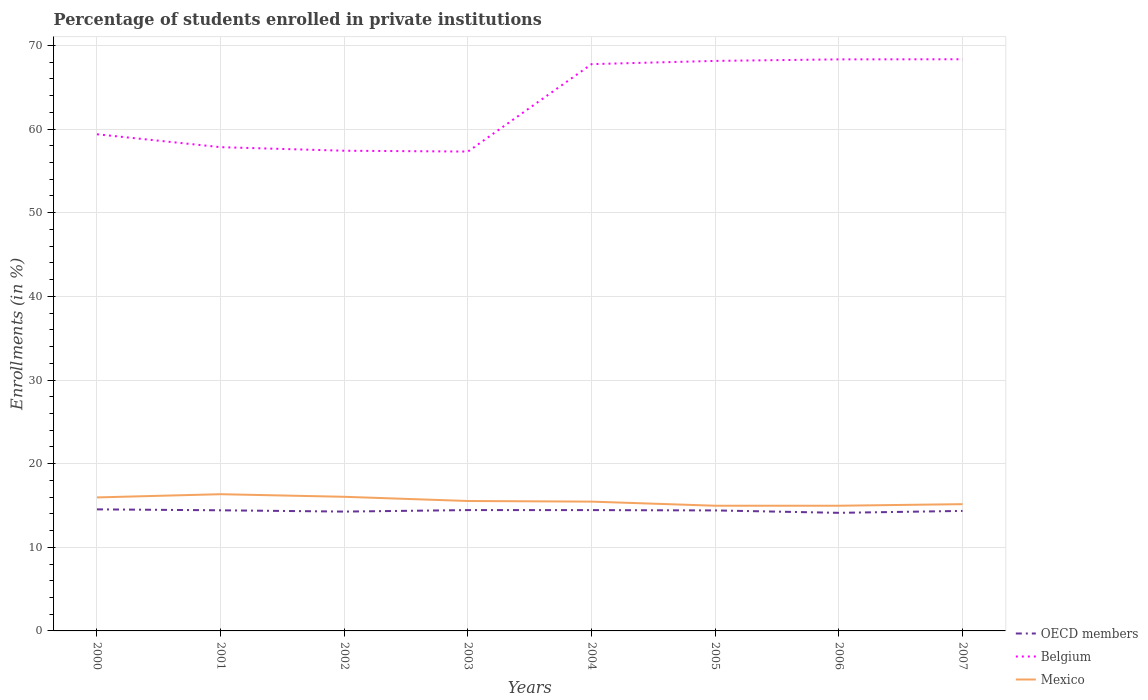Does the line corresponding to Mexico intersect with the line corresponding to OECD members?
Offer a terse response. No. Is the number of lines equal to the number of legend labels?
Provide a short and direct response. Yes. Across all years, what is the maximum percentage of trained teachers in Mexico?
Your answer should be compact. 14.97. What is the total percentage of trained teachers in Belgium in the graph?
Your answer should be compact. -11.04. What is the difference between the highest and the second highest percentage of trained teachers in OECD members?
Your answer should be compact. 0.42. What is the difference between two consecutive major ticks on the Y-axis?
Ensure brevity in your answer.  10. Does the graph contain any zero values?
Your answer should be very brief. No. Does the graph contain grids?
Your answer should be very brief. Yes. Where does the legend appear in the graph?
Your answer should be compact. Bottom right. How are the legend labels stacked?
Provide a short and direct response. Vertical. What is the title of the graph?
Your response must be concise. Percentage of students enrolled in private institutions. Does "Nicaragua" appear as one of the legend labels in the graph?
Your response must be concise. No. What is the label or title of the X-axis?
Provide a short and direct response. Years. What is the label or title of the Y-axis?
Offer a terse response. Enrollments (in %). What is the Enrollments (in %) of OECD members in 2000?
Give a very brief answer. 14.53. What is the Enrollments (in %) in Belgium in 2000?
Provide a succinct answer. 59.38. What is the Enrollments (in %) of Mexico in 2000?
Your answer should be very brief. 15.96. What is the Enrollments (in %) in OECD members in 2001?
Provide a succinct answer. 14.42. What is the Enrollments (in %) of Belgium in 2001?
Ensure brevity in your answer.  57.84. What is the Enrollments (in %) in Mexico in 2001?
Your answer should be very brief. 16.35. What is the Enrollments (in %) of OECD members in 2002?
Your answer should be compact. 14.27. What is the Enrollments (in %) in Belgium in 2002?
Your answer should be compact. 57.41. What is the Enrollments (in %) in Mexico in 2002?
Offer a very short reply. 16.04. What is the Enrollments (in %) in OECD members in 2003?
Provide a succinct answer. 14.45. What is the Enrollments (in %) of Belgium in 2003?
Your answer should be very brief. 57.31. What is the Enrollments (in %) in Mexico in 2003?
Provide a succinct answer. 15.53. What is the Enrollments (in %) of OECD members in 2004?
Ensure brevity in your answer.  14.45. What is the Enrollments (in %) in Belgium in 2004?
Offer a very short reply. 67.77. What is the Enrollments (in %) in Mexico in 2004?
Ensure brevity in your answer.  15.46. What is the Enrollments (in %) in OECD members in 2005?
Offer a terse response. 14.41. What is the Enrollments (in %) in Belgium in 2005?
Give a very brief answer. 68.15. What is the Enrollments (in %) in Mexico in 2005?
Provide a succinct answer. 14.97. What is the Enrollments (in %) in OECD members in 2006?
Keep it short and to the point. 14.12. What is the Enrollments (in %) of Belgium in 2006?
Ensure brevity in your answer.  68.33. What is the Enrollments (in %) in Mexico in 2006?
Keep it short and to the point. 14.97. What is the Enrollments (in %) of OECD members in 2007?
Ensure brevity in your answer.  14.35. What is the Enrollments (in %) of Belgium in 2007?
Your answer should be compact. 68.35. What is the Enrollments (in %) in Mexico in 2007?
Your response must be concise. 15.16. Across all years, what is the maximum Enrollments (in %) in OECD members?
Keep it short and to the point. 14.53. Across all years, what is the maximum Enrollments (in %) in Belgium?
Provide a short and direct response. 68.35. Across all years, what is the maximum Enrollments (in %) of Mexico?
Provide a short and direct response. 16.35. Across all years, what is the minimum Enrollments (in %) in OECD members?
Provide a succinct answer. 14.12. Across all years, what is the minimum Enrollments (in %) in Belgium?
Your answer should be compact. 57.31. Across all years, what is the minimum Enrollments (in %) in Mexico?
Ensure brevity in your answer.  14.97. What is the total Enrollments (in %) of OECD members in the graph?
Your response must be concise. 114.99. What is the total Enrollments (in %) in Belgium in the graph?
Your response must be concise. 504.55. What is the total Enrollments (in %) of Mexico in the graph?
Provide a short and direct response. 124.43. What is the difference between the Enrollments (in %) in OECD members in 2000 and that in 2001?
Your response must be concise. 0.11. What is the difference between the Enrollments (in %) of Belgium in 2000 and that in 2001?
Give a very brief answer. 1.54. What is the difference between the Enrollments (in %) in Mexico in 2000 and that in 2001?
Give a very brief answer. -0.38. What is the difference between the Enrollments (in %) of OECD members in 2000 and that in 2002?
Your answer should be very brief. 0.27. What is the difference between the Enrollments (in %) in Belgium in 2000 and that in 2002?
Keep it short and to the point. 1.97. What is the difference between the Enrollments (in %) in Mexico in 2000 and that in 2002?
Make the answer very short. -0.08. What is the difference between the Enrollments (in %) in OECD members in 2000 and that in 2003?
Your response must be concise. 0.09. What is the difference between the Enrollments (in %) in Belgium in 2000 and that in 2003?
Provide a succinct answer. 2.07. What is the difference between the Enrollments (in %) of Mexico in 2000 and that in 2003?
Keep it short and to the point. 0.43. What is the difference between the Enrollments (in %) of OECD members in 2000 and that in 2004?
Provide a short and direct response. 0.09. What is the difference between the Enrollments (in %) in Belgium in 2000 and that in 2004?
Offer a terse response. -8.39. What is the difference between the Enrollments (in %) of Mexico in 2000 and that in 2004?
Provide a short and direct response. 0.5. What is the difference between the Enrollments (in %) of OECD members in 2000 and that in 2005?
Keep it short and to the point. 0.13. What is the difference between the Enrollments (in %) in Belgium in 2000 and that in 2005?
Keep it short and to the point. -8.77. What is the difference between the Enrollments (in %) of OECD members in 2000 and that in 2006?
Offer a very short reply. 0.42. What is the difference between the Enrollments (in %) of Belgium in 2000 and that in 2006?
Keep it short and to the point. -8.95. What is the difference between the Enrollments (in %) of OECD members in 2000 and that in 2007?
Give a very brief answer. 0.19. What is the difference between the Enrollments (in %) in Belgium in 2000 and that in 2007?
Your answer should be very brief. -8.97. What is the difference between the Enrollments (in %) of Mexico in 2000 and that in 2007?
Your answer should be compact. 0.81. What is the difference between the Enrollments (in %) in OECD members in 2001 and that in 2002?
Ensure brevity in your answer.  0.15. What is the difference between the Enrollments (in %) of Belgium in 2001 and that in 2002?
Keep it short and to the point. 0.43. What is the difference between the Enrollments (in %) of Mexico in 2001 and that in 2002?
Ensure brevity in your answer.  0.31. What is the difference between the Enrollments (in %) in OECD members in 2001 and that in 2003?
Offer a terse response. -0.03. What is the difference between the Enrollments (in %) in Belgium in 2001 and that in 2003?
Give a very brief answer. 0.52. What is the difference between the Enrollments (in %) in Mexico in 2001 and that in 2003?
Your answer should be very brief. 0.81. What is the difference between the Enrollments (in %) in OECD members in 2001 and that in 2004?
Your response must be concise. -0.02. What is the difference between the Enrollments (in %) in Belgium in 2001 and that in 2004?
Give a very brief answer. -9.93. What is the difference between the Enrollments (in %) in Mexico in 2001 and that in 2004?
Your answer should be compact. 0.89. What is the difference between the Enrollments (in %) in OECD members in 2001 and that in 2005?
Your response must be concise. 0.02. What is the difference between the Enrollments (in %) in Belgium in 2001 and that in 2005?
Offer a terse response. -10.31. What is the difference between the Enrollments (in %) in Mexico in 2001 and that in 2005?
Your answer should be very brief. 1.38. What is the difference between the Enrollments (in %) in OECD members in 2001 and that in 2006?
Offer a very short reply. 0.3. What is the difference between the Enrollments (in %) of Belgium in 2001 and that in 2006?
Ensure brevity in your answer.  -10.5. What is the difference between the Enrollments (in %) of Mexico in 2001 and that in 2006?
Give a very brief answer. 1.38. What is the difference between the Enrollments (in %) in OECD members in 2001 and that in 2007?
Your answer should be compact. 0.07. What is the difference between the Enrollments (in %) in Belgium in 2001 and that in 2007?
Your answer should be compact. -10.51. What is the difference between the Enrollments (in %) in Mexico in 2001 and that in 2007?
Offer a terse response. 1.19. What is the difference between the Enrollments (in %) of OECD members in 2002 and that in 2003?
Make the answer very short. -0.18. What is the difference between the Enrollments (in %) in Belgium in 2002 and that in 2003?
Ensure brevity in your answer.  0.1. What is the difference between the Enrollments (in %) of Mexico in 2002 and that in 2003?
Provide a succinct answer. 0.5. What is the difference between the Enrollments (in %) in OECD members in 2002 and that in 2004?
Your response must be concise. -0.18. What is the difference between the Enrollments (in %) of Belgium in 2002 and that in 2004?
Make the answer very short. -10.36. What is the difference between the Enrollments (in %) of Mexico in 2002 and that in 2004?
Provide a short and direct response. 0.58. What is the difference between the Enrollments (in %) in OECD members in 2002 and that in 2005?
Ensure brevity in your answer.  -0.14. What is the difference between the Enrollments (in %) of Belgium in 2002 and that in 2005?
Make the answer very short. -10.74. What is the difference between the Enrollments (in %) of Mexico in 2002 and that in 2005?
Keep it short and to the point. 1.07. What is the difference between the Enrollments (in %) in OECD members in 2002 and that in 2006?
Ensure brevity in your answer.  0.15. What is the difference between the Enrollments (in %) of Belgium in 2002 and that in 2006?
Provide a short and direct response. -10.92. What is the difference between the Enrollments (in %) in Mexico in 2002 and that in 2006?
Make the answer very short. 1.07. What is the difference between the Enrollments (in %) of OECD members in 2002 and that in 2007?
Offer a terse response. -0.08. What is the difference between the Enrollments (in %) of Belgium in 2002 and that in 2007?
Provide a succinct answer. -10.94. What is the difference between the Enrollments (in %) of Mexico in 2002 and that in 2007?
Offer a very short reply. 0.88. What is the difference between the Enrollments (in %) of OECD members in 2003 and that in 2004?
Give a very brief answer. 0. What is the difference between the Enrollments (in %) in Belgium in 2003 and that in 2004?
Give a very brief answer. -10.45. What is the difference between the Enrollments (in %) in Mexico in 2003 and that in 2004?
Your answer should be very brief. 0.07. What is the difference between the Enrollments (in %) of OECD members in 2003 and that in 2005?
Offer a terse response. 0.04. What is the difference between the Enrollments (in %) of Belgium in 2003 and that in 2005?
Offer a very short reply. -10.84. What is the difference between the Enrollments (in %) of Mexico in 2003 and that in 2005?
Ensure brevity in your answer.  0.57. What is the difference between the Enrollments (in %) of OECD members in 2003 and that in 2006?
Offer a very short reply. 0.33. What is the difference between the Enrollments (in %) of Belgium in 2003 and that in 2006?
Provide a short and direct response. -11.02. What is the difference between the Enrollments (in %) in Mexico in 2003 and that in 2006?
Your response must be concise. 0.57. What is the difference between the Enrollments (in %) in OECD members in 2003 and that in 2007?
Provide a short and direct response. 0.1. What is the difference between the Enrollments (in %) in Belgium in 2003 and that in 2007?
Offer a terse response. -11.04. What is the difference between the Enrollments (in %) in Mexico in 2003 and that in 2007?
Your answer should be compact. 0.38. What is the difference between the Enrollments (in %) of OECD members in 2004 and that in 2005?
Offer a terse response. 0.04. What is the difference between the Enrollments (in %) of Belgium in 2004 and that in 2005?
Make the answer very short. -0.39. What is the difference between the Enrollments (in %) in Mexico in 2004 and that in 2005?
Keep it short and to the point. 0.49. What is the difference between the Enrollments (in %) in OECD members in 2004 and that in 2006?
Your response must be concise. 0.33. What is the difference between the Enrollments (in %) in Belgium in 2004 and that in 2006?
Make the answer very short. -0.57. What is the difference between the Enrollments (in %) in Mexico in 2004 and that in 2006?
Give a very brief answer. 0.49. What is the difference between the Enrollments (in %) in OECD members in 2004 and that in 2007?
Offer a terse response. 0.1. What is the difference between the Enrollments (in %) in Belgium in 2004 and that in 2007?
Keep it short and to the point. -0.58. What is the difference between the Enrollments (in %) in Mexico in 2004 and that in 2007?
Your response must be concise. 0.3. What is the difference between the Enrollments (in %) in OECD members in 2005 and that in 2006?
Give a very brief answer. 0.29. What is the difference between the Enrollments (in %) of Belgium in 2005 and that in 2006?
Give a very brief answer. -0.18. What is the difference between the Enrollments (in %) of Mexico in 2005 and that in 2006?
Provide a succinct answer. 0. What is the difference between the Enrollments (in %) of OECD members in 2005 and that in 2007?
Your answer should be compact. 0.06. What is the difference between the Enrollments (in %) in Belgium in 2005 and that in 2007?
Make the answer very short. -0.2. What is the difference between the Enrollments (in %) in Mexico in 2005 and that in 2007?
Your answer should be compact. -0.19. What is the difference between the Enrollments (in %) of OECD members in 2006 and that in 2007?
Your response must be concise. -0.23. What is the difference between the Enrollments (in %) of Belgium in 2006 and that in 2007?
Ensure brevity in your answer.  -0.01. What is the difference between the Enrollments (in %) of Mexico in 2006 and that in 2007?
Make the answer very short. -0.19. What is the difference between the Enrollments (in %) of OECD members in 2000 and the Enrollments (in %) of Belgium in 2001?
Your answer should be very brief. -43.3. What is the difference between the Enrollments (in %) in OECD members in 2000 and the Enrollments (in %) in Mexico in 2001?
Provide a succinct answer. -1.81. What is the difference between the Enrollments (in %) in Belgium in 2000 and the Enrollments (in %) in Mexico in 2001?
Provide a succinct answer. 43.03. What is the difference between the Enrollments (in %) of OECD members in 2000 and the Enrollments (in %) of Belgium in 2002?
Your answer should be very brief. -42.88. What is the difference between the Enrollments (in %) of OECD members in 2000 and the Enrollments (in %) of Mexico in 2002?
Your answer should be compact. -1.5. What is the difference between the Enrollments (in %) of Belgium in 2000 and the Enrollments (in %) of Mexico in 2002?
Your response must be concise. 43.34. What is the difference between the Enrollments (in %) of OECD members in 2000 and the Enrollments (in %) of Belgium in 2003?
Offer a terse response. -42.78. What is the difference between the Enrollments (in %) of OECD members in 2000 and the Enrollments (in %) of Mexico in 2003?
Make the answer very short. -1. What is the difference between the Enrollments (in %) of Belgium in 2000 and the Enrollments (in %) of Mexico in 2003?
Offer a very short reply. 43.85. What is the difference between the Enrollments (in %) of OECD members in 2000 and the Enrollments (in %) of Belgium in 2004?
Your answer should be very brief. -53.23. What is the difference between the Enrollments (in %) of OECD members in 2000 and the Enrollments (in %) of Mexico in 2004?
Offer a terse response. -0.92. What is the difference between the Enrollments (in %) of Belgium in 2000 and the Enrollments (in %) of Mexico in 2004?
Your response must be concise. 43.92. What is the difference between the Enrollments (in %) of OECD members in 2000 and the Enrollments (in %) of Belgium in 2005?
Make the answer very short. -53.62. What is the difference between the Enrollments (in %) in OECD members in 2000 and the Enrollments (in %) in Mexico in 2005?
Ensure brevity in your answer.  -0.43. What is the difference between the Enrollments (in %) in Belgium in 2000 and the Enrollments (in %) in Mexico in 2005?
Offer a terse response. 44.41. What is the difference between the Enrollments (in %) of OECD members in 2000 and the Enrollments (in %) of Belgium in 2006?
Your answer should be very brief. -53.8. What is the difference between the Enrollments (in %) of OECD members in 2000 and the Enrollments (in %) of Mexico in 2006?
Make the answer very short. -0.43. What is the difference between the Enrollments (in %) of Belgium in 2000 and the Enrollments (in %) of Mexico in 2006?
Provide a succinct answer. 44.41. What is the difference between the Enrollments (in %) in OECD members in 2000 and the Enrollments (in %) in Belgium in 2007?
Provide a succinct answer. -53.81. What is the difference between the Enrollments (in %) of OECD members in 2000 and the Enrollments (in %) of Mexico in 2007?
Provide a short and direct response. -0.62. What is the difference between the Enrollments (in %) in Belgium in 2000 and the Enrollments (in %) in Mexico in 2007?
Keep it short and to the point. 44.22. What is the difference between the Enrollments (in %) of OECD members in 2001 and the Enrollments (in %) of Belgium in 2002?
Offer a very short reply. -42.99. What is the difference between the Enrollments (in %) of OECD members in 2001 and the Enrollments (in %) of Mexico in 2002?
Provide a short and direct response. -1.61. What is the difference between the Enrollments (in %) in Belgium in 2001 and the Enrollments (in %) in Mexico in 2002?
Your answer should be compact. 41.8. What is the difference between the Enrollments (in %) in OECD members in 2001 and the Enrollments (in %) in Belgium in 2003?
Provide a short and direct response. -42.89. What is the difference between the Enrollments (in %) of OECD members in 2001 and the Enrollments (in %) of Mexico in 2003?
Keep it short and to the point. -1.11. What is the difference between the Enrollments (in %) in Belgium in 2001 and the Enrollments (in %) in Mexico in 2003?
Your response must be concise. 42.3. What is the difference between the Enrollments (in %) of OECD members in 2001 and the Enrollments (in %) of Belgium in 2004?
Provide a short and direct response. -53.34. What is the difference between the Enrollments (in %) of OECD members in 2001 and the Enrollments (in %) of Mexico in 2004?
Your answer should be very brief. -1.04. What is the difference between the Enrollments (in %) in Belgium in 2001 and the Enrollments (in %) in Mexico in 2004?
Offer a terse response. 42.38. What is the difference between the Enrollments (in %) of OECD members in 2001 and the Enrollments (in %) of Belgium in 2005?
Provide a short and direct response. -53.73. What is the difference between the Enrollments (in %) in OECD members in 2001 and the Enrollments (in %) in Mexico in 2005?
Your answer should be very brief. -0.55. What is the difference between the Enrollments (in %) in Belgium in 2001 and the Enrollments (in %) in Mexico in 2005?
Your answer should be very brief. 42.87. What is the difference between the Enrollments (in %) of OECD members in 2001 and the Enrollments (in %) of Belgium in 2006?
Your response must be concise. -53.91. What is the difference between the Enrollments (in %) in OECD members in 2001 and the Enrollments (in %) in Mexico in 2006?
Give a very brief answer. -0.55. What is the difference between the Enrollments (in %) of Belgium in 2001 and the Enrollments (in %) of Mexico in 2006?
Offer a very short reply. 42.87. What is the difference between the Enrollments (in %) in OECD members in 2001 and the Enrollments (in %) in Belgium in 2007?
Offer a very short reply. -53.93. What is the difference between the Enrollments (in %) in OECD members in 2001 and the Enrollments (in %) in Mexico in 2007?
Ensure brevity in your answer.  -0.73. What is the difference between the Enrollments (in %) in Belgium in 2001 and the Enrollments (in %) in Mexico in 2007?
Provide a succinct answer. 42.68. What is the difference between the Enrollments (in %) of OECD members in 2002 and the Enrollments (in %) of Belgium in 2003?
Provide a short and direct response. -43.05. What is the difference between the Enrollments (in %) in OECD members in 2002 and the Enrollments (in %) in Mexico in 2003?
Ensure brevity in your answer.  -1.27. What is the difference between the Enrollments (in %) in Belgium in 2002 and the Enrollments (in %) in Mexico in 2003?
Your answer should be compact. 41.88. What is the difference between the Enrollments (in %) of OECD members in 2002 and the Enrollments (in %) of Belgium in 2004?
Make the answer very short. -53.5. What is the difference between the Enrollments (in %) of OECD members in 2002 and the Enrollments (in %) of Mexico in 2004?
Give a very brief answer. -1.19. What is the difference between the Enrollments (in %) in Belgium in 2002 and the Enrollments (in %) in Mexico in 2004?
Your answer should be very brief. 41.95. What is the difference between the Enrollments (in %) of OECD members in 2002 and the Enrollments (in %) of Belgium in 2005?
Make the answer very short. -53.89. What is the difference between the Enrollments (in %) of OECD members in 2002 and the Enrollments (in %) of Mexico in 2005?
Offer a terse response. -0.7. What is the difference between the Enrollments (in %) in Belgium in 2002 and the Enrollments (in %) in Mexico in 2005?
Your answer should be compact. 42.44. What is the difference between the Enrollments (in %) of OECD members in 2002 and the Enrollments (in %) of Belgium in 2006?
Offer a very short reply. -54.07. What is the difference between the Enrollments (in %) of OECD members in 2002 and the Enrollments (in %) of Mexico in 2006?
Your response must be concise. -0.7. What is the difference between the Enrollments (in %) in Belgium in 2002 and the Enrollments (in %) in Mexico in 2006?
Provide a succinct answer. 42.44. What is the difference between the Enrollments (in %) of OECD members in 2002 and the Enrollments (in %) of Belgium in 2007?
Provide a short and direct response. -54.08. What is the difference between the Enrollments (in %) in OECD members in 2002 and the Enrollments (in %) in Mexico in 2007?
Ensure brevity in your answer.  -0.89. What is the difference between the Enrollments (in %) of Belgium in 2002 and the Enrollments (in %) of Mexico in 2007?
Your response must be concise. 42.26. What is the difference between the Enrollments (in %) of OECD members in 2003 and the Enrollments (in %) of Belgium in 2004?
Your answer should be compact. -53.32. What is the difference between the Enrollments (in %) in OECD members in 2003 and the Enrollments (in %) in Mexico in 2004?
Give a very brief answer. -1.01. What is the difference between the Enrollments (in %) in Belgium in 2003 and the Enrollments (in %) in Mexico in 2004?
Make the answer very short. 41.85. What is the difference between the Enrollments (in %) of OECD members in 2003 and the Enrollments (in %) of Belgium in 2005?
Keep it short and to the point. -53.7. What is the difference between the Enrollments (in %) in OECD members in 2003 and the Enrollments (in %) in Mexico in 2005?
Make the answer very short. -0.52. What is the difference between the Enrollments (in %) in Belgium in 2003 and the Enrollments (in %) in Mexico in 2005?
Ensure brevity in your answer.  42.35. What is the difference between the Enrollments (in %) of OECD members in 2003 and the Enrollments (in %) of Belgium in 2006?
Make the answer very short. -53.89. What is the difference between the Enrollments (in %) of OECD members in 2003 and the Enrollments (in %) of Mexico in 2006?
Your answer should be compact. -0.52. What is the difference between the Enrollments (in %) in Belgium in 2003 and the Enrollments (in %) in Mexico in 2006?
Offer a very short reply. 42.35. What is the difference between the Enrollments (in %) in OECD members in 2003 and the Enrollments (in %) in Belgium in 2007?
Offer a terse response. -53.9. What is the difference between the Enrollments (in %) of OECD members in 2003 and the Enrollments (in %) of Mexico in 2007?
Offer a very short reply. -0.71. What is the difference between the Enrollments (in %) of Belgium in 2003 and the Enrollments (in %) of Mexico in 2007?
Give a very brief answer. 42.16. What is the difference between the Enrollments (in %) in OECD members in 2004 and the Enrollments (in %) in Belgium in 2005?
Your answer should be compact. -53.71. What is the difference between the Enrollments (in %) in OECD members in 2004 and the Enrollments (in %) in Mexico in 2005?
Offer a terse response. -0.52. What is the difference between the Enrollments (in %) of Belgium in 2004 and the Enrollments (in %) of Mexico in 2005?
Make the answer very short. 52.8. What is the difference between the Enrollments (in %) of OECD members in 2004 and the Enrollments (in %) of Belgium in 2006?
Offer a very short reply. -53.89. What is the difference between the Enrollments (in %) in OECD members in 2004 and the Enrollments (in %) in Mexico in 2006?
Keep it short and to the point. -0.52. What is the difference between the Enrollments (in %) of Belgium in 2004 and the Enrollments (in %) of Mexico in 2006?
Ensure brevity in your answer.  52.8. What is the difference between the Enrollments (in %) in OECD members in 2004 and the Enrollments (in %) in Belgium in 2007?
Offer a terse response. -53.9. What is the difference between the Enrollments (in %) in OECD members in 2004 and the Enrollments (in %) in Mexico in 2007?
Offer a terse response. -0.71. What is the difference between the Enrollments (in %) of Belgium in 2004 and the Enrollments (in %) of Mexico in 2007?
Keep it short and to the point. 52.61. What is the difference between the Enrollments (in %) of OECD members in 2005 and the Enrollments (in %) of Belgium in 2006?
Your answer should be compact. -53.93. What is the difference between the Enrollments (in %) in OECD members in 2005 and the Enrollments (in %) in Mexico in 2006?
Your answer should be very brief. -0.56. What is the difference between the Enrollments (in %) in Belgium in 2005 and the Enrollments (in %) in Mexico in 2006?
Keep it short and to the point. 53.18. What is the difference between the Enrollments (in %) of OECD members in 2005 and the Enrollments (in %) of Belgium in 2007?
Your response must be concise. -53.94. What is the difference between the Enrollments (in %) in OECD members in 2005 and the Enrollments (in %) in Mexico in 2007?
Offer a terse response. -0.75. What is the difference between the Enrollments (in %) of Belgium in 2005 and the Enrollments (in %) of Mexico in 2007?
Your response must be concise. 53. What is the difference between the Enrollments (in %) in OECD members in 2006 and the Enrollments (in %) in Belgium in 2007?
Your answer should be very brief. -54.23. What is the difference between the Enrollments (in %) of OECD members in 2006 and the Enrollments (in %) of Mexico in 2007?
Offer a terse response. -1.04. What is the difference between the Enrollments (in %) in Belgium in 2006 and the Enrollments (in %) in Mexico in 2007?
Your response must be concise. 53.18. What is the average Enrollments (in %) in OECD members per year?
Your response must be concise. 14.37. What is the average Enrollments (in %) in Belgium per year?
Your answer should be compact. 63.07. What is the average Enrollments (in %) of Mexico per year?
Offer a very short reply. 15.55. In the year 2000, what is the difference between the Enrollments (in %) of OECD members and Enrollments (in %) of Belgium?
Provide a short and direct response. -44.85. In the year 2000, what is the difference between the Enrollments (in %) of OECD members and Enrollments (in %) of Mexico?
Ensure brevity in your answer.  -1.43. In the year 2000, what is the difference between the Enrollments (in %) in Belgium and Enrollments (in %) in Mexico?
Offer a very short reply. 43.42. In the year 2001, what is the difference between the Enrollments (in %) of OECD members and Enrollments (in %) of Belgium?
Your response must be concise. -43.42. In the year 2001, what is the difference between the Enrollments (in %) of OECD members and Enrollments (in %) of Mexico?
Make the answer very short. -1.92. In the year 2001, what is the difference between the Enrollments (in %) of Belgium and Enrollments (in %) of Mexico?
Make the answer very short. 41.49. In the year 2002, what is the difference between the Enrollments (in %) of OECD members and Enrollments (in %) of Belgium?
Your answer should be compact. -43.14. In the year 2002, what is the difference between the Enrollments (in %) of OECD members and Enrollments (in %) of Mexico?
Provide a succinct answer. -1.77. In the year 2002, what is the difference between the Enrollments (in %) of Belgium and Enrollments (in %) of Mexico?
Keep it short and to the point. 41.38. In the year 2003, what is the difference between the Enrollments (in %) in OECD members and Enrollments (in %) in Belgium?
Make the answer very short. -42.87. In the year 2003, what is the difference between the Enrollments (in %) in OECD members and Enrollments (in %) in Mexico?
Offer a very short reply. -1.09. In the year 2003, what is the difference between the Enrollments (in %) in Belgium and Enrollments (in %) in Mexico?
Ensure brevity in your answer.  41.78. In the year 2004, what is the difference between the Enrollments (in %) in OECD members and Enrollments (in %) in Belgium?
Your response must be concise. -53.32. In the year 2004, what is the difference between the Enrollments (in %) in OECD members and Enrollments (in %) in Mexico?
Keep it short and to the point. -1.01. In the year 2004, what is the difference between the Enrollments (in %) in Belgium and Enrollments (in %) in Mexico?
Keep it short and to the point. 52.31. In the year 2005, what is the difference between the Enrollments (in %) in OECD members and Enrollments (in %) in Belgium?
Ensure brevity in your answer.  -53.75. In the year 2005, what is the difference between the Enrollments (in %) of OECD members and Enrollments (in %) of Mexico?
Provide a short and direct response. -0.56. In the year 2005, what is the difference between the Enrollments (in %) of Belgium and Enrollments (in %) of Mexico?
Your answer should be very brief. 53.18. In the year 2006, what is the difference between the Enrollments (in %) of OECD members and Enrollments (in %) of Belgium?
Keep it short and to the point. -54.22. In the year 2006, what is the difference between the Enrollments (in %) of OECD members and Enrollments (in %) of Mexico?
Your answer should be compact. -0.85. In the year 2006, what is the difference between the Enrollments (in %) of Belgium and Enrollments (in %) of Mexico?
Keep it short and to the point. 53.37. In the year 2007, what is the difference between the Enrollments (in %) of OECD members and Enrollments (in %) of Belgium?
Provide a succinct answer. -54. In the year 2007, what is the difference between the Enrollments (in %) in OECD members and Enrollments (in %) in Mexico?
Offer a terse response. -0.81. In the year 2007, what is the difference between the Enrollments (in %) in Belgium and Enrollments (in %) in Mexico?
Your response must be concise. 53.19. What is the ratio of the Enrollments (in %) of Belgium in 2000 to that in 2001?
Make the answer very short. 1.03. What is the ratio of the Enrollments (in %) of Mexico in 2000 to that in 2001?
Make the answer very short. 0.98. What is the ratio of the Enrollments (in %) of OECD members in 2000 to that in 2002?
Ensure brevity in your answer.  1.02. What is the ratio of the Enrollments (in %) of Belgium in 2000 to that in 2002?
Offer a very short reply. 1.03. What is the ratio of the Enrollments (in %) in OECD members in 2000 to that in 2003?
Your response must be concise. 1.01. What is the ratio of the Enrollments (in %) of Belgium in 2000 to that in 2003?
Offer a very short reply. 1.04. What is the ratio of the Enrollments (in %) of Mexico in 2000 to that in 2003?
Your response must be concise. 1.03. What is the ratio of the Enrollments (in %) of OECD members in 2000 to that in 2004?
Make the answer very short. 1.01. What is the ratio of the Enrollments (in %) in Belgium in 2000 to that in 2004?
Make the answer very short. 0.88. What is the ratio of the Enrollments (in %) of Mexico in 2000 to that in 2004?
Your response must be concise. 1.03. What is the ratio of the Enrollments (in %) of OECD members in 2000 to that in 2005?
Keep it short and to the point. 1.01. What is the ratio of the Enrollments (in %) of Belgium in 2000 to that in 2005?
Provide a short and direct response. 0.87. What is the ratio of the Enrollments (in %) in Mexico in 2000 to that in 2005?
Offer a terse response. 1.07. What is the ratio of the Enrollments (in %) in OECD members in 2000 to that in 2006?
Ensure brevity in your answer.  1.03. What is the ratio of the Enrollments (in %) of Belgium in 2000 to that in 2006?
Offer a very short reply. 0.87. What is the ratio of the Enrollments (in %) in Mexico in 2000 to that in 2006?
Make the answer very short. 1.07. What is the ratio of the Enrollments (in %) of Belgium in 2000 to that in 2007?
Give a very brief answer. 0.87. What is the ratio of the Enrollments (in %) in Mexico in 2000 to that in 2007?
Make the answer very short. 1.05. What is the ratio of the Enrollments (in %) in OECD members in 2001 to that in 2002?
Give a very brief answer. 1.01. What is the ratio of the Enrollments (in %) in Belgium in 2001 to that in 2002?
Give a very brief answer. 1.01. What is the ratio of the Enrollments (in %) in Mexico in 2001 to that in 2002?
Provide a succinct answer. 1.02. What is the ratio of the Enrollments (in %) of OECD members in 2001 to that in 2003?
Your answer should be compact. 1. What is the ratio of the Enrollments (in %) in Belgium in 2001 to that in 2003?
Your response must be concise. 1.01. What is the ratio of the Enrollments (in %) of Mexico in 2001 to that in 2003?
Your answer should be very brief. 1.05. What is the ratio of the Enrollments (in %) in OECD members in 2001 to that in 2004?
Offer a terse response. 1. What is the ratio of the Enrollments (in %) of Belgium in 2001 to that in 2004?
Your answer should be very brief. 0.85. What is the ratio of the Enrollments (in %) of Mexico in 2001 to that in 2004?
Ensure brevity in your answer.  1.06. What is the ratio of the Enrollments (in %) of Belgium in 2001 to that in 2005?
Give a very brief answer. 0.85. What is the ratio of the Enrollments (in %) of Mexico in 2001 to that in 2005?
Your response must be concise. 1.09. What is the ratio of the Enrollments (in %) in OECD members in 2001 to that in 2006?
Make the answer very short. 1.02. What is the ratio of the Enrollments (in %) in Belgium in 2001 to that in 2006?
Your answer should be very brief. 0.85. What is the ratio of the Enrollments (in %) in Mexico in 2001 to that in 2006?
Offer a very short reply. 1.09. What is the ratio of the Enrollments (in %) of OECD members in 2001 to that in 2007?
Your response must be concise. 1.01. What is the ratio of the Enrollments (in %) in Belgium in 2001 to that in 2007?
Offer a terse response. 0.85. What is the ratio of the Enrollments (in %) in Mexico in 2001 to that in 2007?
Keep it short and to the point. 1.08. What is the ratio of the Enrollments (in %) of OECD members in 2002 to that in 2003?
Keep it short and to the point. 0.99. What is the ratio of the Enrollments (in %) in Belgium in 2002 to that in 2003?
Offer a terse response. 1. What is the ratio of the Enrollments (in %) of Mexico in 2002 to that in 2003?
Provide a succinct answer. 1.03. What is the ratio of the Enrollments (in %) in OECD members in 2002 to that in 2004?
Give a very brief answer. 0.99. What is the ratio of the Enrollments (in %) of Belgium in 2002 to that in 2004?
Ensure brevity in your answer.  0.85. What is the ratio of the Enrollments (in %) of Mexico in 2002 to that in 2004?
Keep it short and to the point. 1.04. What is the ratio of the Enrollments (in %) in OECD members in 2002 to that in 2005?
Provide a short and direct response. 0.99. What is the ratio of the Enrollments (in %) in Belgium in 2002 to that in 2005?
Provide a short and direct response. 0.84. What is the ratio of the Enrollments (in %) of Mexico in 2002 to that in 2005?
Keep it short and to the point. 1.07. What is the ratio of the Enrollments (in %) in OECD members in 2002 to that in 2006?
Your answer should be very brief. 1.01. What is the ratio of the Enrollments (in %) in Belgium in 2002 to that in 2006?
Your response must be concise. 0.84. What is the ratio of the Enrollments (in %) in Mexico in 2002 to that in 2006?
Offer a terse response. 1.07. What is the ratio of the Enrollments (in %) in Belgium in 2002 to that in 2007?
Offer a terse response. 0.84. What is the ratio of the Enrollments (in %) of Mexico in 2002 to that in 2007?
Your response must be concise. 1.06. What is the ratio of the Enrollments (in %) of Belgium in 2003 to that in 2004?
Your answer should be very brief. 0.85. What is the ratio of the Enrollments (in %) in Mexico in 2003 to that in 2004?
Your answer should be compact. 1. What is the ratio of the Enrollments (in %) of OECD members in 2003 to that in 2005?
Ensure brevity in your answer.  1. What is the ratio of the Enrollments (in %) of Belgium in 2003 to that in 2005?
Ensure brevity in your answer.  0.84. What is the ratio of the Enrollments (in %) of Mexico in 2003 to that in 2005?
Your response must be concise. 1.04. What is the ratio of the Enrollments (in %) in OECD members in 2003 to that in 2006?
Offer a terse response. 1.02. What is the ratio of the Enrollments (in %) in Belgium in 2003 to that in 2006?
Your answer should be compact. 0.84. What is the ratio of the Enrollments (in %) in Mexico in 2003 to that in 2006?
Ensure brevity in your answer.  1.04. What is the ratio of the Enrollments (in %) of OECD members in 2003 to that in 2007?
Your answer should be very brief. 1.01. What is the ratio of the Enrollments (in %) in Belgium in 2003 to that in 2007?
Make the answer very short. 0.84. What is the ratio of the Enrollments (in %) of OECD members in 2004 to that in 2005?
Offer a very short reply. 1. What is the ratio of the Enrollments (in %) of Mexico in 2004 to that in 2005?
Give a very brief answer. 1.03. What is the ratio of the Enrollments (in %) in OECD members in 2004 to that in 2006?
Your answer should be very brief. 1.02. What is the ratio of the Enrollments (in %) in Mexico in 2004 to that in 2006?
Provide a succinct answer. 1.03. What is the ratio of the Enrollments (in %) of Mexico in 2004 to that in 2007?
Give a very brief answer. 1.02. What is the ratio of the Enrollments (in %) of OECD members in 2005 to that in 2006?
Make the answer very short. 1.02. What is the ratio of the Enrollments (in %) in Belgium in 2005 to that in 2006?
Your response must be concise. 1. What is the ratio of the Enrollments (in %) in OECD members in 2005 to that in 2007?
Your answer should be compact. 1. What is the ratio of the Enrollments (in %) in Belgium in 2005 to that in 2007?
Provide a short and direct response. 1. What is the ratio of the Enrollments (in %) in Mexico in 2005 to that in 2007?
Ensure brevity in your answer.  0.99. What is the ratio of the Enrollments (in %) of Mexico in 2006 to that in 2007?
Keep it short and to the point. 0.99. What is the difference between the highest and the second highest Enrollments (in %) in OECD members?
Offer a very short reply. 0.09. What is the difference between the highest and the second highest Enrollments (in %) of Belgium?
Offer a very short reply. 0.01. What is the difference between the highest and the second highest Enrollments (in %) in Mexico?
Provide a succinct answer. 0.31. What is the difference between the highest and the lowest Enrollments (in %) of OECD members?
Your answer should be compact. 0.42. What is the difference between the highest and the lowest Enrollments (in %) in Belgium?
Give a very brief answer. 11.04. What is the difference between the highest and the lowest Enrollments (in %) of Mexico?
Provide a short and direct response. 1.38. 